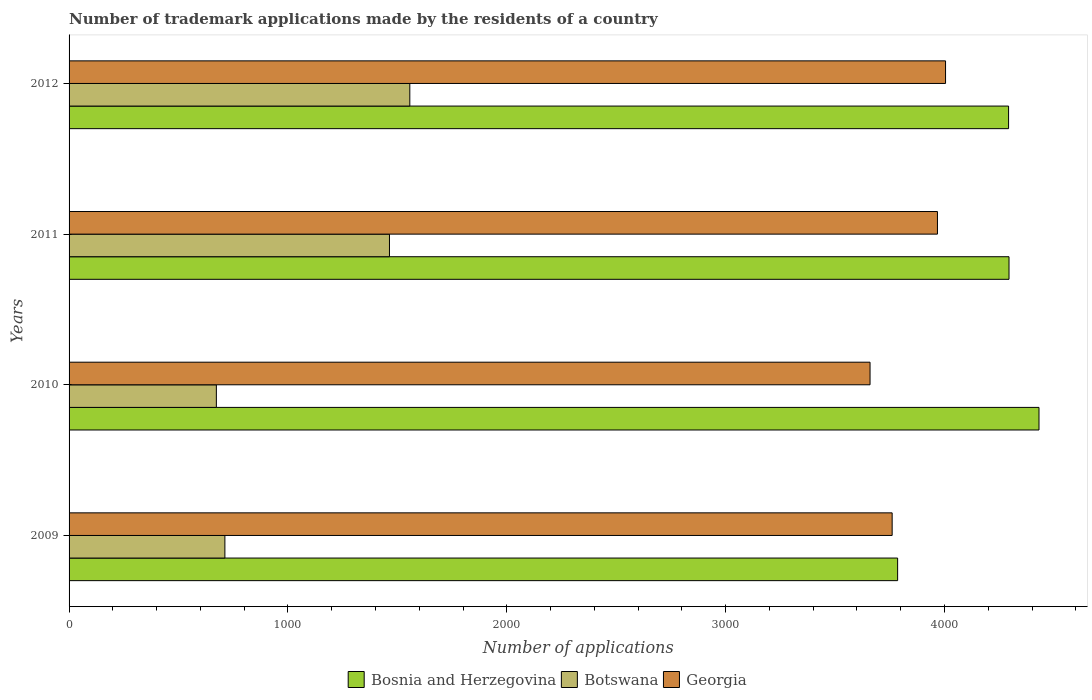How many bars are there on the 1st tick from the top?
Offer a very short reply. 3. What is the label of the 4th group of bars from the top?
Offer a very short reply. 2009. In how many cases, is the number of bars for a given year not equal to the number of legend labels?
Keep it short and to the point. 0. What is the number of trademark applications made by the residents in Bosnia and Herzegovina in 2009?
Ensure brevity in your answer.  3786. Across all years, what is the maximum number of trademark applications made by the residents in Bosnia and Herzegovina?
Provide a succinct answer. 4432. Across all years, what is the minimum number of trademark applications made by the residents in Botswana?
Provide a succinct answer. 673. In which year was the number of trademark applications made by the residents in Georgia maximum?
Provide a short and direct response. 2012. In which year was the number of trademark applications made by the residents in Botswana minimum?
Your answer should be very brief. 2010. What is the total number of trademark applications made by the residents in Bosnia and Herzegovina in the graph?
Your answer should be compact. 1.68e+04. What is the difference between the number of trademark applications made by the residents in Georgia in 2011 and that in 2012?
Provide a short and direct response. -37. What is the difference between the number of trademark applications made by the residents in Botswana in 2010 and the number of trademark applications made by the residents in Bosnia and Herzegovina in 2011?
Give a very brief answer. -3622. What is the average number of trademark applications made by the residents in Georgia per year?
Offer a terse response. 3848.5. In the year 2010, what is the difference between the number of trademark applications made by the residents in Bosnia and Herzegovina and number of trademark applications made by the residents in Georgia?
Provide a short and direct response. 772. In how many years, is the number of trademark applications made by the residents in Botswana greater than 2200 ?
Ensure brevity in your answer.  0. What is the ratio of the number of trademark applications made by the residents in Botswana in 2009 to that in 2011?
Provide a short and direct response. 0.49. Is the number of trademark applications made by the residents in Georgia in 2011 less than that in 2012?
Your answer should be compact. Yes. Is the difference between the number of trademark applications made by the residents in Bosnia and Herzegovina in 2011 and 2012 greater than the difference between the number of trademark applications made by the residents in Georgia in 2011 and 2012?
Give a very brief answer. Yes. What is the difference between the highest and the second highest number of trademark applications made by the residents in Botswana?
Your answer should be very brief. 93. What is the difference between the highest and the lowest number of trademark applications made by the residents in Georgia?
Provide a short and direct response. 345. Is the sum of the number of trademark applications made by the residents in Bosnia and Herzegovina in 2009 and 2012 greater than the maximum number of trademark applications made by the residents in Georgia across all years?
Offer a terse response. Yes. What does the 1st bar from the top in 2009 represents?
Make the answer very short. Georgia. What does the 2nd bar from the bottom in 2011 represents?
Your response must be concise. Botswana. How many bars are there?
Your answer should be compact. 12. Are all the bars in the graph horizontal?
Offer a terse response. Yes. How many years are there in the graph?
Provide a succinct answer. 4. Are the values on the major ticks of X-axis written in scientific E-notation?
Give a very brief answer. No. Does the graph contain any zero values?
Your response must be concise. No. How many legend labels are there?
Provide a succinct answer. 3. How are the legend labels stacked?
Ensure brevity in your answer.  Horizontal. What is the title of the graph?
Give a very brief answer. Number of trademark applications made by the residents of a country. Does "New Zealand" appear as one of the legend labels in the graph?
Make the answer very short. No. What is the label or title of the X-axis?
Offer a very short reply. Number of applications. What is the label or title of the Y-axis?
Give a very brief answer. Years. What is the Number of applications of Bosnia and Herzegovina in 2009?
Provide a short and direct response. 3786. What is the Number of applications of Botswana in 2009?
Your answer should be very brief. 712. What is the Number of applications of Georgia in 2009?
Keep it short and to the point. 3761. What is the Number of applications of Bosnia and Herzegovina in 2010?
Your answer should be very brief. 4432. What is the Number of applications in Botswana in 2010?
Your response must be concise. 673. What is the Number of applications of Georgia in 2010?
Keep it short and to the point. 3660. What is the Number of applications of Bosnia and Herzegovina in 2011?
Offer a terse response. 4295. What is the Number of applications of Botswana in 2011?
Offer a terse response. 1464. What is the Number of applications of Georgia in 2011?
Offer a very short reply. 3968. What is the Number of applications of Bosnia and Herzegovina in 2012?
Your answer should be compact. 4293. What is the Number of applications in Botswana in 2012?
Provide a short and direct response. 1557. What is the Number of applications in Georgia in 2012?
Provide a short and direct response. 4005. Across all years, what is the maximum Number of applications of Bosnia and Herzegovina?
Your answer should be compact. 4432. Across all years, what is the maximum Number of applications of Botswana?
Your response must be concise. 1557. Across all years, what is the maximum Number of applications in Georgia?
Keep it short and to the point. 4005. Across all years, what is the minimum Number of applications of Bosnia and Herzegovina?
Offer a terse response. 3786. Across all years, what is the minimum Number of applications in Botswana?
Keep it short and to the point. 673. Across all years, what is the minimum Number of applications of Georgia?
Give a very brief answer. 3660. What is the total Number of applications in Bosnia and Herzegovina in the graph?
Your response must be concise. 1.68e+04. What is the total Number of applications in Botswana in the graph?
Your answer should be compact. 4406. What is the total Number of applications of Georgia in the graph?
Offer a very short reply. 1.54e+04. What is the difference between the Number of applications in Bosnia and Herzegovina in 2009 and that in 2010?
Give a very brief answer. -646. What is the difference between the Number of applications in Botswana in 2009 and that in 2010?
Your answer should be compact. 39. What is the difference between the Number of applications of Georgia in 2009 and that in 2010?
Your answer should be very brief. 101. What is the difference between the Number of applications in Bosnia and Herzegovina in 2009 and that in 2011?
Your answer should be very brief. -509. What is the difference between the Number of applications in Botswana in 2009 and that in 2011?
Provide a succinct answer. -752. What is the difference between the Number of applications of Georgia in 2009 and that in 2011?
Your answer should be very brief. -207. What is the difference between the Number of applications of Bosnia and Herzegovina in 2009 and that in 2012?
Provide a short and direct response. -507. What is the difference between the Number of applications in Botswana in 2009 and that in 2012?
Your answer should be very brief. -845. What is the difference between the Number of applications of Georgia in 2009 and that in 2012?
Your answer should be compact. -244. What is the difference between the Number of applications of Bosnia and Herzegovina in 2010 and that in 2011?
Ensure brevity in your answer.  137. What is the difference between the Number of applications in Botswana in 2010 and that in 2011?
Provide a succinct answer. -791. What is the difference between the Number of applications in Georgia in 2010 and that in 2011?
Your answer should be very brief. -308. What is the difference between the Number of applications in Bosnia and Herzegovina in 2010 and that in 2012?
Provide a short and direct response. 139. What is the difference between the Number of applications of Botswana in 2010 and that in 2012?
Make the answer very short. -884. What is the difference between the Number of applications in Georgia in 2010 and that in 2012?
Your response must be concise. -345. What is the difference between the Number of applications of Botswana in 2011 and that in 2012?
Your response must be concise. -93. What is the difference between the Number of applications in Georgia in 2011 and that in 2012?
Offer a terse response. -37. What is the difference between the Number of applications in Bosnia and Herzegovina in 2009 and the Number of applications in Botswana in 2010?
Make the answer very short. 3113. What is the difference between the Number of applications in Bosnia and Herzegovina in 2009 and the Number of applications in Georgia in 2010?
Provide a succinct answer. 126. What is the difference between the Number of applications of Botswana in 2009 and the Number of applications of Georgia in 2010?
Ensure brevity in your answer.  -2948. What is the difference between the Number of applications in Bosnia and Herzegovina in 2009 and the Number of applications in Botswana in 2011?
Your answer should be very brief. 2322. What is the difference between the Number of applications in Bosnia and Herzegovina in 2009 and the Number of applications in Georgia in 2011?
Give a very brief answer. -182. What is the difference between the Number of applications in Botswana in 2009 and the Number of applications in Georgia in 2011?
Offer a very short reply. -3256. What is the difference between the Number of applications of Bosnia and Herzegovina in 2009 and the Number of applications of Botswana in 2012?
Provide a short and direct response. 2229. What is the difference between the Number of applications of Bosnia and Herzegovina in 2009 and the Number of applications of Georgia in 2012?
Your answer should be very brief. -219. What is the difference between the Number of applications of Botswana in 2009 and the Number of applications of Georgia in 2012?
Keep it short and to the point. -3293. What is the difference between the Number of applications of Bosnia and Herzegovina in 2010 and the Number of applications of Botswana in 2011?
Make the answer very short. 2968. What is the difference between the Number of applications of Bosnia and Herzegovina in 2010 and the Number of applications of Georgia in 2011?
Your answer should be very brief. 464. What is the difference between the Number of applications of Botswana in 2010 and the Number of applications of Georgia in 2011?
Your response must be concise. -3295. What is the difference between the Number of applications of Bosnia and Herzegovina in 2010 and the Number of applications of Botswana in 2012?
Keep it short and to the point. 2875. What is the difference between the Number of applications in Bosnia and Herzegovina in 2010 and the Number of applications in Georgia in 2012?
Provide a succinct answer. 427. What is the difference between the Number of applications of Botswana in 2010 and the Number of applications of Georgia in 2012?
Make the answer very short. -3332. What is the difference between the Number of applications of Bosnia and Herzegovina in 2011 and the Number of applications of Botswana in 2012?
Provide a succinct answer. 2738. What is the difference between the Number of applications in Bosnia and Herzegovina in 2011 and the Number of applications in Georgia in 2012?
Offer a terse response. 290. What is the difference between the Number of applications in Botswana in 2011 and the Number of applications in Georgia in 2012?
Make the answer very short. -2541. What is the average Number of applications of Bosnia and Herzegovina per year?
Offer a very short reply. 4201.5. What is the average Number of applications in Botswana per year?
Your answer should be compact. 1101.5. What is the average Number of applications in Georgia per year?
Give a very brief answer. 3848.5. In the year 2009, what is the difference between the Number of applications in Bosnia and Herzegovina and Number of applications in Botswana?
Provide a succinct answer. 3074. In the year 2009, what is the difference between the Number of applications of Botswana and Number of applications of Georgia?
Your answer should be very brief. -3049. In the year 2010, what is the difference between the Number of applications in Bosnia and Herzegovina and Number of applications in Botswana?
Offer a very short reply. 3759. In the year 2010, what is the difference between the Number of applications in Bosnia and Herzegovina and Number of applications in Georgia?
Give a very brief answer. 772. In the year 2010, what is the difference between the Number of applications in Botswana and Number of applications in Georgia?
Provide a succinct answer. -2987. In the year 2011, what is the difference between the Number of applications of Bosnia and Herzegovina and Number of applications of Botswana?
Your answer should be compact. 2831. In the year 2011, what is the difference between the Number of applications in Bosnia and Herzegovina and Number of applications in Georgia?
Offer a very short reply. 327. In the year 2011, what is the difference between the Number of applications in Botswana and Number of applications in Georgia?
Your answer should be compact. -2504. In the year 2012, what is the difference between the Number of applications of Bosnia and Herzegovina and Number of applications of Botswana?
Offer a terse response. 2736. In the year 2012, what is the difference between the Number of applications of Bosnia and Herzegovina and Number of applications of Georgia?
Your answer should be compact. 288. In the year 2012, what is the difference between the Number of applications in Botswana and Number of applications in Georgia?
Provide a short and direct response. -2448. What is the ratio of the Number of applications of Bosnia and Herzegovina in 2009 to that in 2010?
Provide a short and direct response. 0.85. What is the ratio of the Number of applications of Botswana in 2009 to that in 2010?
Ensure brevity in your answer.  1.06. What is the ratio of the Number of applications of Georgia in 2009 to that in 2010?
Offer a terse response. 1.03. What is the ratio of the Number of applications of Bosnia and Herzegovina in 2009 to that in 2011?
Make the answer very short. 0.88. What is the ratio of the Number of applications of Botswana in 2009 to that in 2011?
Keep it short and to the point. 0.49. What is the ratio of the Number of applications of Georgia in 2009 to that in 2011?
Your answer should be very brief. 0.95. What is the ratio of the Number of applications of Bosnia and Herzegovina in 2009 to that in 2012?
Provide a succinct answer. 0.88. What is the ratio of the Number of applications in Botswana in 2009 to that in 2012?
Provide a short and direct response. 0.46. What is the ratio of the Number of applications of Georgia in 2009 to that in 2012?
Offer a very short reply. 0.94. What is the ratio of the Number of applications in Bosnia and Herzegovina in 2010 to that in 2011?
Offer a very short reply. 1.03. What is the ratio of the Number of applications in Botswana in 2010 to that in 2011?
Ensure brevity in your answer.  0.46. What is the ratio of the Number of applications in Georgia in 2010 to that in 2011?
Provide a succinct answer. 0.92. What is the ratio of the Number of applications in Bosnia and Herzegovina in 2010 to that in 2012?
Offer a terse response. 1.03. What is the ratio of the Number of applications of Botswana in 2010 to that in 2012?
Your response must be concise. 0.43. What is the ratio of the Number of applications of Georgia in 2010 to that in 2012?
Provide a succinct answer. 0.91. What is the ratio of the Number of applications of Bosnia and Herzegovina in 2011 to that in 2012?
Your answer should be very brief. 1. What is the ratio of the Number of applications of Botswana in 2011 to that in 2012?
Give a very brief answer. 0.94. What is the ratio of the Number of applications in Georgia in 2011 to that in 2012?
Give a very brief answer. 0.99. What is the difference between the highest and the second highest Number of applications of Bosnia and Herzegovina?
Provide a succinct answer. 137. What is the difference between the highest and the second highest Number of applications of Botswana?
Provide a short and direct response. 93. What is the difference between the highest and the lowest Number of applications in Bosnia and Herzegovina?
Offer a very short reply. 646. What is the difference between the highest and the lowest Number of applications of Botswana?
Offer a very short reply. 884. What is the difference between the highest and the lowest Number of applications in Georgia?
Give a very brief answer. 345. 